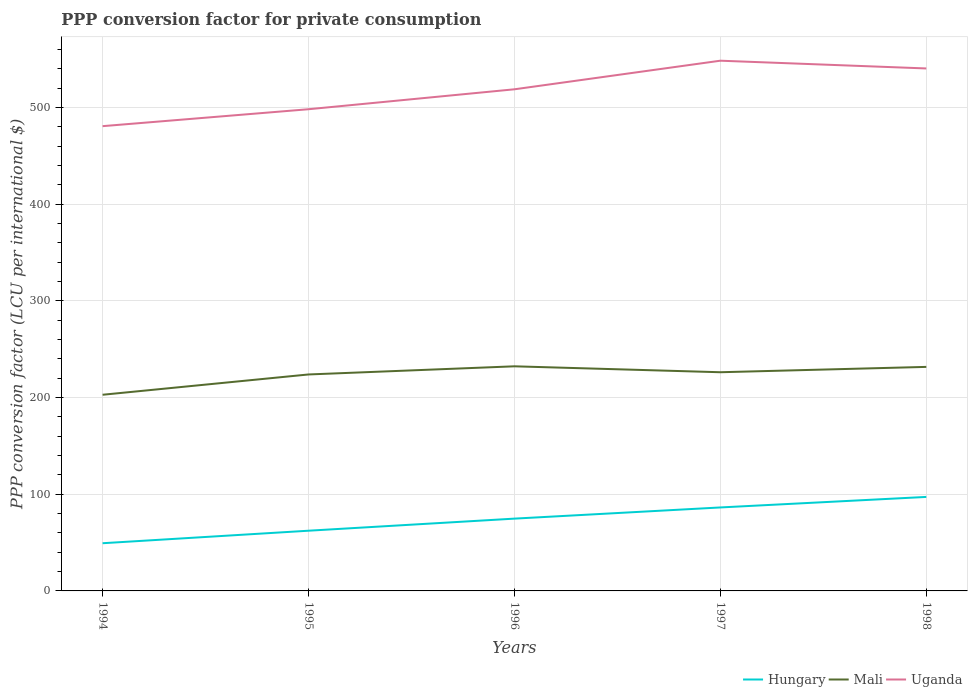How many different coloured lines are there?
Your answer should be very brief. 3. Does the line corresponding to Mali intersect with the line corresponding to Hungary?
Offer a terse response. No. Is the number of lines equal to the number of legend labels?
Offer a very short reply. Yes. Across all years, what is the maximum PPP conversion factor for private consumption in Mali?
Ensure brevity in your answer.  202.94. What is the total PPP conversion factor for private consumption in Mali in the graph?
Give a very brief answer. -8.43. What is the difference between the highest and the second highest PPP conversion factor for private consumption in Hungary?
Offer a very short reply. 47.9. What is the difference between the highest and the lowest PPP conversion factor for private consumption in Hungary?
Offer a very short reply. 3. How many lines are there?
Your response must be concise. 3. Are the values on the major ticks of Y-axis written in scientific E-notation?
Your answer should be very brief. No. Does the graph contain grids?
Provide a short and direct response. Yes. How many legend labels are there?
Provide a short and direct response. 3. What is the title of the graph?
Ensure brevity in your answer.  PPP conversion factor for private consumption. What is the label or title of the X-axis?
Keep it short and to the point. Years. What is the label or title of the Y-axis?
Offer a very short reply. PPP conversion factor (LCU per international $). What is the PPP conversion factor (LCU per international $) of Hungary in 1994?
Offer a very short reply. 49.34. What is the PPP conversion factor (LCU per international $) of Mali in 1994?
Provide a succinct answer. 202.94. What is the PPP conversion factor (LCU per international $) of Uganda in 1994?
Make the answer very short. 480.83. What is the PPP conversion factor (LCU per international $) of Hungary in 1995?
Your response must be concise. 62.29. What is the PPP conversion factor (LCU per international $) in Mali in 1995?
Your answer should be very brief. 223.94. What is the PPP conversion factor (LCU per international $) in Uganda in 1995?
Give a very brief answer. 498.34. What is the PPP conversion factor (LCU per international $) in Hungary in 1996?
Your answer should be very brief. 74.79. What is the PPP conversion factor (LCU per international $) in Mali in 1996?
Ensure brevity in your answer.  232.37. What is the PPP conversion factor (LCU per international $) of Uganda in 1996?
Your answer should be compact. 518.97. What is the PPP conversion factor (LCU per international $) of Hungary in 1997?
Your response must be concise. 86.36. What is the PPP conversion factor (LCU per international $) in Mali in 1997?
Ensure brevity in your answer.  226.24. What is the PPP conversion factor (LCU per international $) in Uganda in 1997?
Your answer should be compact. 548.54. What is the PPP conversion factor (LCU per international $) of Hungary in 1998?
Keep it short and to the point. 97.24. What is the PPP conversion factor (LCU per international $) of Mali in 1998?
Your response must be concise. 231.77. What is the PPP conversion factor (LCU per international $) of Uganda in 1998?
Keep it short and to the point. 540.53. Across all years, what is the maximum PPP conversion factor (LCU per international $) of Hungary?
Provide a succinct answer. 97.24. Across all years, what is the maximum PPP conversion factor (LCU per international $) of Mali?
Make the answer very short. 232.37. Across all years, what is the maximum PPP conversion factor (LCU per international $) in Uganda?
Offer a terse response. 548.54. Across all years, what is the minimum PPP conversion factor (LCU per international $) of Hungary?
Your answer should be very brief. 49.34. Across all years, what is the minimum PPP conversion factor (LCU per international $) in Mali?
Your response must be concise. 202.94. Across all years, what is the minimum PPP conversion factor (LCU per international $) in Uganda?
Your answer should be very brief. 480.83. What is the total PPP conversion factor (LCU per international $) of Hungary in the graph?
Your answer should be very brief. 370.03. What is the total PPP conversion factor (LCU per international $) of Mali in the graph?
Keep it short and to the point. 1117.27. What is the total PPP conversion factor (LCU per international $) in Uganda in the graph?
Your answer should be compact. 2587.22. What is the difference between the PPP conversion factor (LCU per international $) in Hungary in 1994 and that in 1995?
Make the answer very short. -12.95. What is the difference between the PPP conversion factor (LCU per international $) of Mali in 1994 and that in 1995?
Your answer should be very brief. -21. What is the difference between the PPP conversion factor (LCU per international $) in Uganda in 1994 and that in 1995?
Your answer should be very brief. -17.51. What is the difference between the PPP conversion factor (LCU per international $) in Hungary in 1994 and that in 1996?
Provide a succinct answer. -25.45. What is the difference between the PPP conversion factor (LCU per international $) in Mali in 1994 and that in 1996?
Your answer should be very brief. -29.43. What is the difference between the PPP conversion factor (LCU per international $) of Uganda in 1994 and that in 1996?
Your answer should be compact. -38.14. What is the difference between the PPP conversion factor (LCU per international $) of Hungary in 1994 and that in 1997?
Provide a succinct answer. -37.02. What is the difference between the PPP conversion factor (LCU per international $) in Mali in 1994 and that in 1997?
Give a very brief answer. -23.29. What is the difference between the PPP conversion factor (LCU per international $) of Uganda in 1994 and that in 1997?
Your answer should be very brief. -67.71. What is the difference between the PPP conversion factor (LCU per international $) of Hungary in 1994 and that in 1998?
Your response must be concise. -47.9. What is the difference between the PPP conversion factor (LCU per international $) of Mali in 1994 and that in 1998?
Your answer should be compact. -28.83. What is the difference between the PPP conversion factor (LCU per international $) of Uganda in 1994 and that in 1998?
Provide a succinct answer. -59.7. What is the difference between the PPP conversion factor (LCU per international $) in Hungary in 1995 and that in 1996?
Your response must be concise. -12.5. What is the difference between the PPP conversion factor (LCU per international $) of Mali in 1995 and that in 1996?
Offer a very short reply. -8.43. What is the difference between the PPP conversion factor (LCU per international $) of Uganda in 1995 and that in 1996?
Provide a succinct answer. -20.63. What is the difference between the PPP conversion factor (LCU per international $) in Hungary in 1995 and that in 1997?
Your answer should be very brief. -24.07. What is the difference between the PPP conversion factor (LCU per international $) in Mali in 1995 and that in 1997?
Offer a very short reply. -2.3. What is the difference between the PPP conversion factor (LCU per international $) in Uganda in 1995 and that in 1997?
Offer a very short reply. -50.2. What is the difference between the PPP conversion factor (LCU per international $) of Hungary in 1995 and that in 1998?
Provide a short and direct response. -34.95. What is the difference between the PPP conversion factor (LCU per international $) of Mali in 1995 and that in 1998?
Your answer should be very brief. -7.83. What is the difference between the PPP conversion factor (LCU per international $) of Uganda in 1995 and that in 1998?
Offer a terse response. -42.19. What is the difference between the PPP conversion factor (LCU per international $) in Hungary in 1996 and that in 1997?
Give a very brief answer. -11.57. What is the difference between the PPP conversion factor (LCU per international $) in Mali in 1996 and that in 1997?
Keep it short and to the point. 6.13. What is the difference between the PPP conversion factor (LCU per international $) in Uganda in 1996 and that in 1997?
Make the answer very short. -29.57. What is the difference between the PPP conversion factor (LCU per international $) in Hungary in 1996 and that in 1998?
Make the answer very short. -22.45. What is the difference between the PPP conversion factor (LCU per international $) in Mali in 1996 and that in 1998?
Provide a short and direct response. 0.6. What is the difference between the PPP conversion factor (LCU per international $) of Uganda in 1996 and that in 1998?
Offer a very short reply. -21.56. What is the difference between the PPP conversion factor (LCU per international $) of Hungary in 1997 and that in 1998?
Ensure brevity in your answer.  -10.88. What is the difference between the PPP conversion factor (LCU per international $) in Mali in 1997 and that in 1998?
Provide a succinct answer. -5.53. What is the difference between the PPP conversion factor (LCU per international $) of Uganda in 1997 and that in 1998?
Make the answer very short. 8.01. What is the difference between the PPP conversion factor (LCU per international $) of Hungary in 1994 and the PPP conversion factor (LCU per international $) of Mali in 1995?
Give a very brief answer. -174.6. What is the difference between the PPP conversion factor (LCU per international $) of Hungary in 1994 and the PPP conversion factor (LCU per international $) of Uganda in 1995?
Keep it short and to the point. -449. What is the difference between the PPP conversion factor (LCU per international $) in Mali in 1994 and the PPP conversion factor (LCU per international $) in Uganda in 1995?
Give a very brief answer. -295.4. What is the difference between the PPP conversion factor (LCU per international $) of Hungary in 1994 and the PPP conversion factor (LCU per international $) of Mali in 1996?
Give a very brief answer. -183.03. What is the difference between the PPP conversion factor (LCU per international $) in Hungary in 1994 and the PPP conversion factor (LCU per international $) in Uganda in 1996?
Your answer should be compact. -469.63. What is the difference between the PPP conversion factor (LCU per international $) in Mali in 1994 and the PPP conversion factor (LCU per international $) in Uganda in 1996?
Your answer should be very brief. -316.03. What is the difference between the PPP conversion factor (LCU per international $) of Hungary in 1994 and the PPP conversion factor (LCU per international $) of Mali in 1997?
Offer a very short reply. -176.9. What is the difference between the PPP conversion factor (LCU per international $) of Hungary in 1994 and the PPP conversion factor (LCU per international $) of Uganda in 1997?
Provide a succinct answer. -499.2. What is the difference between the PPP conversion factor (LCU per international $) of Mali in 1994 and the PPP conversion factor (LCU per international $) of Uganda in 1997?
Your answer should be very brief. -345.6. What is the difference between the PPP conversion factor (LCU per international $) of Hungary in 1994 and the PPP conversion factor (LCU per international $) of Mali in 1998?
Provide a succinct answer. -182.43. What is the difference between the PPP conversion factor (LCU per international $) of Hungary in 1994 and the PPP conversion factor (LCU per international $) of Uganda in 1998?
Your answer should be compact. -491.19. What is the difference between the PPP conversion factor (LCU per international $) in Mali in 1994 and the PPP conversion factor (LCU per international $) in Uganda in 1998?
Offer a terse response. -337.59. What is the difference between the PPP conversion factor (LCU per international $) in Hungary in 1995 and the PPP conversion factor (LCU per international $) in Mali in 1996?
Make the answer very short. -170.08. What is the difference between the PPP conversion factor (LCU per international $) of Hungary in 1995 and the PPP conversion factor (LCU per international $) of Uganda in 1996?
Your response must be concise. -456.68. What is the difference between the PPP conversion factor (LCU per international $) in Mali in 1995 and the PPP conversion factor (LCU per international $) in Uganda in 1996?
Offer a very short reply. -295.03. What is the difference between the PPP conversion factor (LCU per international $) of Hungary in 1995 and the PPP conversion factor (LCU per international $) of Mali in 1997?
Offer a very short reply. -163.95. What is the difference between the PPP conversion factor (LCU per international $) of Hungary in 1995 and the PPP conversion factor (LCU per international $) of Uganda in 1997?
Your answer should be very brief. -486.25. What is the difference between the PPP conversion factor (LCU per international $) in Mali in 1995 and the PPP conversion factor (LCU per international $) in Uganda in 1997?
Your answer should be compact. -324.6. What is the difference between the PPP conversion factor (LCU per international $) in Hungary in 1995 and the PPP conversion factor (LCU per international $) in Mali in 1998?
Provide a short and direct response. -169.48. What is the difference between the PPP conversion factor (LCU per international $) of Hungary in 1995 and the PPP conversion factor (LCU per international $) of Uganda in 1998?
Offer a very short reply. -478.24. What is the difference between the PPP conversion factor (LCU per international $) in Mali in 1995 and the PPP conversion factor (LCU per international $) in Uganda in 1998?
Your response must be concise. -316.59. What is the difference between the PPP conversion factor (LCU per international $) in Hungary in 1996 and the PPP conversion factor (LCU per international $) in Mali in 1997?
Your answer should be very brief. -151.44. What is the difference between the PPP conversion factor (LCU per international $) of Hungary in 1996 and the PPP conversion factor (LCU per international $) of Uganda in 1997?
Your answer should be very brief. -473.75. What is the difference between the PPP conversion factor (LCU per international $) in Mali in 1996 and the PPP conversion factor (LCU per international $) in Uganda in 1997?
Make the answer very short. -316.17. What is the difference between the PPP conversion factor (LCU per international $) of Hungary in 1996 and the PPP conversion factor (LCU per international $) of Mali in 1998?
Give a very brief answer. -156.98. What is the difference between the PPP conversion factor (LCU per international $) of Hungary in 1996 and the PPP conversion factor (LCU per international $) of Uganda in 1998?
Keep it short and to the point. -465.74. What is the difference between the PPP conversion factor (LCU per international $) in Mali in 1996 and the PPP conversion factor (LCU per international $) in Uganda in 1998?
Provide a short and direct response. -308.16. What is the difference between the PPP conversion factor (LCU per international $) of Hungary in 1997 and the PPP conversion factor (LCU per international $) of Mali in 1998?
Provide a succinct answer. -145.41. What is the difference between the PPP conversion factor (LCU per international $) in Hungary in 1997 and the PPP conversion factor (LCU per international $) in Uganda in 1998?
Provide a succinct answer. -454.17. What is the difference between the PPP conversion factor (LCU per international $) of Mali in 1997 and the PPP conversion factor (LCU per international $) of Uganda in 1998?
Your answer should be compact. -314.29. What is the average PPP conversion factor (LCU per international $) of Hungary per year?
Keep it short and to the point. 74.01. What is the average PPP conversion factor (LCU per international $) in Mali per year?
Your answer should be compact. 223.45. What is the average PPP conversion factor (LCU per international $) in Uganda per year?
Your response must be concise. 517.44. In the year 1994, what is the difference between the PPP conversion factor (LCU per international $) of Hungary and PPP conversion factor (LCU per international $) of Mali?
Make the answer very short. -153.6. In the year 1994, what is the difference between the PPP conversion factor (LCU per international $) of Hungary and PPP conversion factor (LCU per international $) of Uganda?
Ensure brevity in your answer.  -431.49. In the year 1994, what is the difference between the PPP conversion factor (LCU per international $) in Mali and PPP conversion factor (LCU per international $) in Uganda?
Your answer should be compact. -277.89. In the year 1995, what is the difference between the PPP conversion factor (LCU per international $) in Hungary and PPP conversion factor (LCU per international $) in Mali?
Your answer should be very brief. -161.65. In the year 1995, what is the difference between the PPP conversion factor (LCU per international $) in Hungary and PPP conversion factor (LCU per international $) in Uganda?
Your response must be concise. -436.05. In the year 1995, what is the difference between the PPP conversion factor (LCU per international $) in Mali and PPP conversion factor (LCU per international $) in Uganda?
Your answer should be very brief. -274.4. In the year 1996, what is the difference between the PPP conversion factor (LCU per international $) in Hungary and PPP conversion factor (LCU per international $) in Mali?
Provide a short and direct response. -157.58. In the year 1996, what is the difference between the PPP conversion factor (LCU per international $) of Hungary and PPP conversion factor (LCU per international $) of Uganda?
Offer a terse response. -444.18. In the year 1996, what is the difference between the PPP conversion factor (LCU per international $) of Mali and PPP conversion factor (LCU per international $) of Uganda?
Provide a succinct answer. -286.6. In the year 1997, what is the difference between the PPP conversion factor (LCU per international $) in Hungary and PPP conversion factor (LCU per international $) in Mali?
Make the answer very short. -139.88. In the year 1997, what is the difference between the PPP conversion factor (LCU per international $) in Hungary and PPP conversion factor (LCU per international $) in Uganda?
Make the answer very short. -462.18. In the year 1997, what is the difference between the PPP conversion factor (LCU per international $) of Mali and PPP conversion factor (LCU per international $) of Uganda?
Your response must be concise. -322.31. In the year 1998, what is the difference between the PPP conversion factor (LCU per international $) in Hungary and PPP conversion factor (LCU per international $) in Mali?
Keep it short and to the point. -134.53. In the year 1998, what is the difference between the PPP conversion factor (LCU per international $) in Hungary and PPP conversion factor (LCU per international $) in Uganda?
Make the answer very short. -443.29. In the year 1998, what is the difference between the PPP conversion factor (LCU per international $) of Mali and PPP conversion factor (LCU per international $) of Uganda?
Your answer should be very brief. -308.76. What is the ratio of the PPP conversion factor (LCU per international $) of Hungary in 1994 to that in 1995?
Offer a terse response. 0.79. What is the ratio of the PPP conversion factor (LCU per international $) in Mali in 1994 to that in 1995?
Keep it short and to the point. 0.91. What is the ratio of the PPP conversion factor (LCU per international $) of Uganda in 1994 to that in 1995?
Give a very brief answer. 0.96. What is the ratio of the PPP conversion factor (LCU per international $) in Hungary in 1994 to that in 1996?
Keep it short and to the point. 0.66. What is the ratio of the PPP conversion factor (LCU per international $) in Mali in 1994 to that in 1996?
Offer a very short reply. 0.87. What is the ratio of the PPP conversion factor (LCU per international $) in Uganda in 1994 to that in 1996?
Your answer should be compact. 0.93. What is the ratio of the PPP conversion factor (LCU per international $) in Hungary in 1994 to that in 1997?
Provide a short and direct response. 0.57. What is the ratio of the PPP conversion factor (LCU per international $) of Mali in 1994 to that in 1997?
Offer a very short reply. 0.9. What is the ratio of the PPP conversion factor (LCU per international $) in Uganda in 1994 to that in 1997?
Your answer should be very brief. 0.88. What is the ratio of the PPP conversion factor (LCU per international $) of Hungary in 1994 to that in 1998?
Make the answer very short. 0.51. What is the ratio of the PPP conversion factor (LCU per international $) of Mali in 1994 to that in 1998?
Give a very brief answer. 0.88. What is the ratio of the PPP conversion factor (LCU per international $) in Uganda in 1994 to that in 1998?
Keep it short and to the point. 0.89. What is the ratio of the PPP conversion factor (LCU per international $) in Hungary in 1995 to that in 1996?
Offer a very short reply. 0.83. What is the ratio of the PPP conversion factor (LCU per international $) in Mali in 1995 to that in 1996?
Your response must be concise. 0.96. What is the ratio of the PPP conversion factor (LCU per international $) in Uganda in 1995 to that in 1996?
Provide a succinct answer. 0.96. What is the ratio of the PPP conversion factor (LCU per international $) in Hungary in 1995 to that in 1997?
Offer a very short reply. 0.72. What is the ratio of the PPP conversion factor (LCU per international $) in Uganda in 1995 to that in 1997?
Your answer should be compact. 0.91. What is the ratio of the PPP conversion factor (LCU per international $) in Hungary in 1995 to that in 1998?
Your answer should be very brief. 0.64. What is the ratio of the PPP conversion factor (LCU per international $) of Mali in 1995 to that in 1998?
Keep it short and to the point. 0.97. What is the ratio of the PPP conversion factor (LCU per international $) in Uganda in 1995 to that in 1998?
Keep it short and to the point. 0.92. What is the ratio of the PPP conversion factor (LCU per international $) of Hungary in 1996 to that in 1997?
Provide a succinct answer. 0.87. What is the ratio of the PPP conversion factor (LCU per international $) of Mali in 1996 to that in 1997?
Your answer should be compact. 1.03. What is the ratio of the PPP conversion factor (LCU per international $) of Uganda in 1996 to that in 1997?
Your answer should be very brief. 0.95. What is the ratio of the PPP conversion factor (LCU per international $) of Hungary in 1996 to that in 1998?
Keep it short and to the point. 0.77. What is the ratio of the PPP conversion factor (LCU per international $) in Mali in 1996 to that in 1998?
Offer a very short reply. 1. What is the ratio of the PPP conversion factor (LCU per international $) in Uganda in 1996 to that in 1998?
Ensure brevity in your answer.  0.96. What is the ratio of the PPP conversion factor (LCU per international $) of Hungary in 1997 to that in 1998?
Give a very brief answer. 0.89. What is the ratio of the PPP conversion factor (LCU per international $) in Mali in 1997 to that in 1998?
Offer a terse response. 0.98. What is the ratio of the PPP conversion factor (LCU per international $) in Uganda in 1997 to that in 1998?
Offer a terse response. 1.01. What is the difference between the highest and the second highest PPP conversion factor (LCU per international $) in Hungary?
Give a very brief answer. 10.88. What is the difference between the highest and the second highest PPP conversion factor (LCU per international $) of Mali?
Give a very brief answer. 0.6. What is the difference between the highest and the second highest PPP conversion factor (LCU per international $) in Uganda?
Give a very brief answer. 8.01. What is the difference between the highest and the lowest PPP conversion factor (LCU per international $) of Hungary?
Ensure brevity in your answer.  47.9. What is the difference between the highest and the lowest PPP conversion factor (LCU per international $) of Mali?
Your answer should be compact. 29.43. What is the difference between the highest and the lowest PPP conversion factor (LCU per international $) of Uganda?
Your response must be concise. 67.71. 